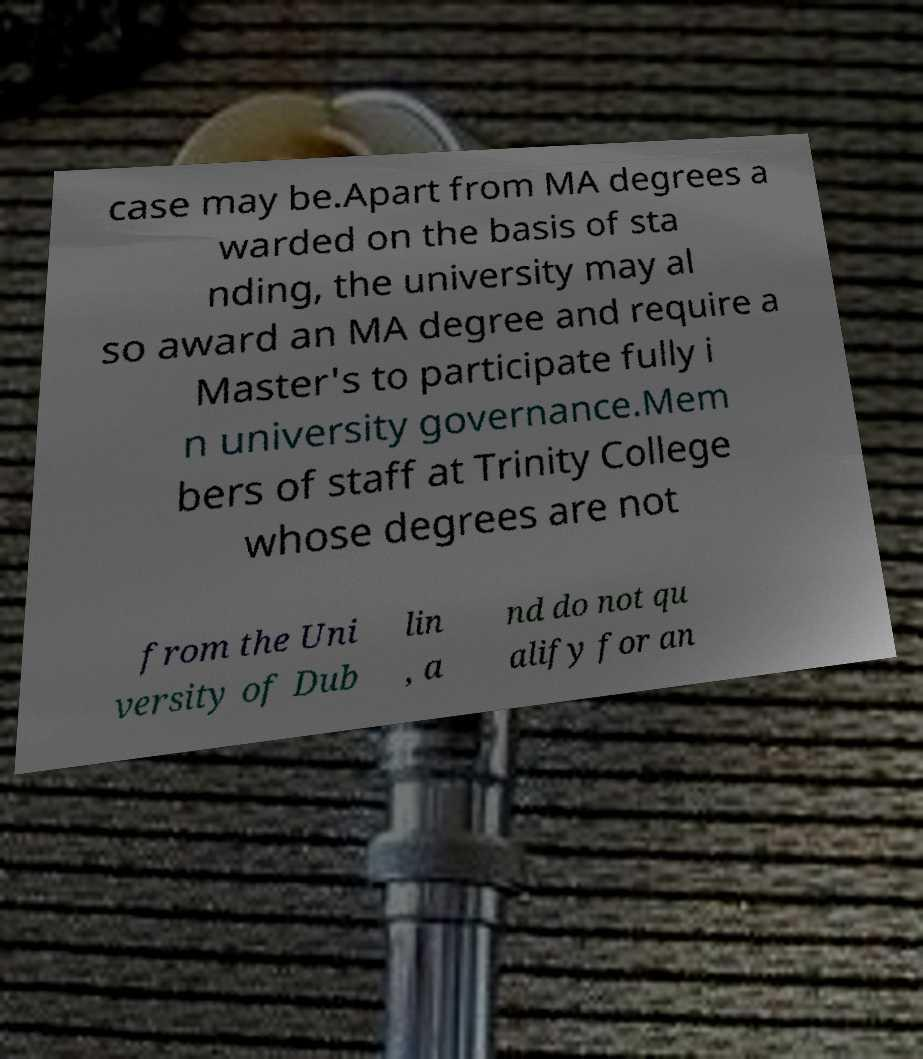There's text embedded in this image that I need extracted. Can you transcribe it verbatim? case may be.Apart from MA degrees a warded on the basis of sta nding, the university may al so award an MA degree and require a Master's to participate fully i n university governance.Mem bers of staff at Trinity College whose degrees are not from the Uni versity of Dub lin , a nd do not qu alify for an 